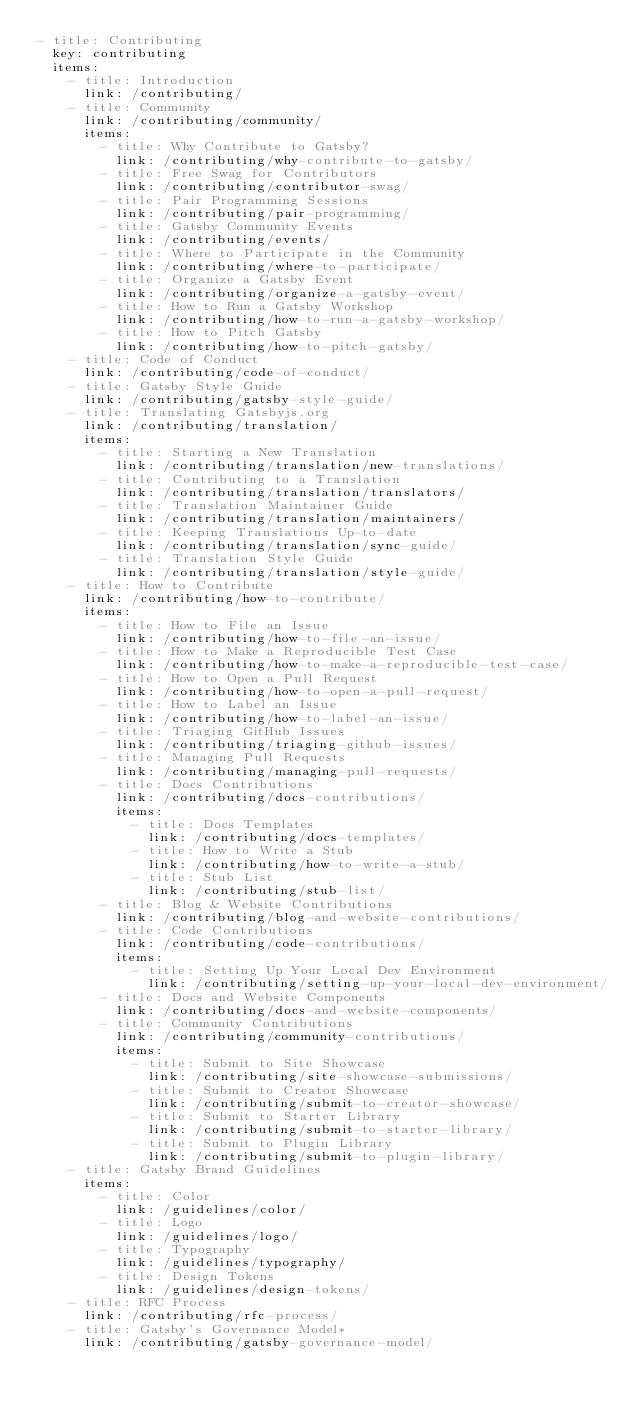Convert code to text. <code><loc_0><loc_0><loc_500><loc_500><_YAML_>- title: Contributing
  key: contributing
  items:
    - title: Introduction
      link: /contributing/
    - title: Community
      link: /contributing/community/
      items:
        - title: Why Contribute to Gatsby?
          link: /contributing/why-contribute-to-gatsby/
        - title: Free Swag for Contributors
          link: /contributing/contributor-swag/
        - title: Pair Programming Sessions
          link: /contributing/pair-programming/
        - title: Gatsby Community Events
          link: /contributing/events/
        - title: Where to Participate in the Community
          link: /contributing/where-to-participate/
        - title: Organize a Gatsby Event
          link: /contributing/organize-a-gatsby-event/
        - title: How to Run a Gatsby Workshop
          link: /contributing/how-to-run-a-gatsby-workshop/
        - title: How to Pitch Gatsby
          link: /contributing/how-to-pitch-gatsby/
    - title: Code of Conduct
      link: /contributing/code-of-conduct/
    - title: Gatsby Style Guide
      link: /contributing/gatsby-style-guide/
    - title: Translating Gatsbyjs.org
      link: /contributing/translation/
      items:
        - title: Starting a New Translation
          link: /contributing/translation/new-translations/
        - title: Contributing to a Translation
          link: /contributing/translation/translators/
        - title: Translation Maintainer Guide
          link: /contributing/translation/maintainers/
        - title: Keeping Translations Up-to-date
          link: /contributing/translation/sync-guide/
        - title: Translation Style Guide
          link: /contributing/translation/style-guide/
    - title: How to Contribute
      link: /contributing/how-to-contribute/
      items:
        - title: How to File an Issue
          link: /contributing/how-to-file-an-issue/
        - title: How to Make a Reproducible Test Case
          link: /contributing/how-to-make-a-reproducible-test-case/
        - title: How to Open a Pull Request
          link: /contributing/how-to-open-a-pull-request/
        - title: How to Label an Issue
          link: /contributing/how-to-label-an-issue/
        - title: Triaging GitHub Issues
          link: /contributing/triaging-github-issues/
        - title: Managing Pull Requests
          link: /contributing/managing-pull-requests/
        - title: Docs Contributions
          link: /contributing/docs-contributions/
          items:
            - title: Docs Templates
              link: /contributing/docs-templates/
            - title: How to Write a Stub
              link: /contributing/how-to-write-a-stub/
            - title: Stub List
              link: /contributing/stub-list/
        - title: Blog & Website Contributions
          link: /contributing/blog-and-website-contributions/
        - title: Code Contributions
          link: /contributing/code-contributions/
          items:
            - title: Setting Up Your Local Dev Environment
              link: /contributing/setting-up-your-local-dev-environment/
        - title: Docs and Website Components
          link: /contributing/docs-and-website-components/
        - title: Community Contributions
          link: /contributing/community-contributions/
          items:
            - title: Submit to Site Showcase
              link: /contributing/site-showcase-submissions/
            - title: Submit to Creator Showcase
              link: /contributing/submit-to-creator-showcase/
            - title: Submit to Starter Library
              link: /contributing/submit-to-starter-library/
            - title: Submit to Plugin Library
              link: /contributing/submit-to-plugin-library/
    - title: Gatsby Brand Guidelines
      items:
        - title: Color
          link: /guidelines/color/
        - title: Logo
          link: /guidelines/logo/
        - title: Typography
          link: /guidelines/typography/
        - title: Design Tokens
          link: /guidelines/design-tokens/
    - title: RFC Process
      link: /contributing/rfc-process/
    - title: Gatsby's Governance Model*
      link: /contributing/gatsby-governance-model/
</code> 